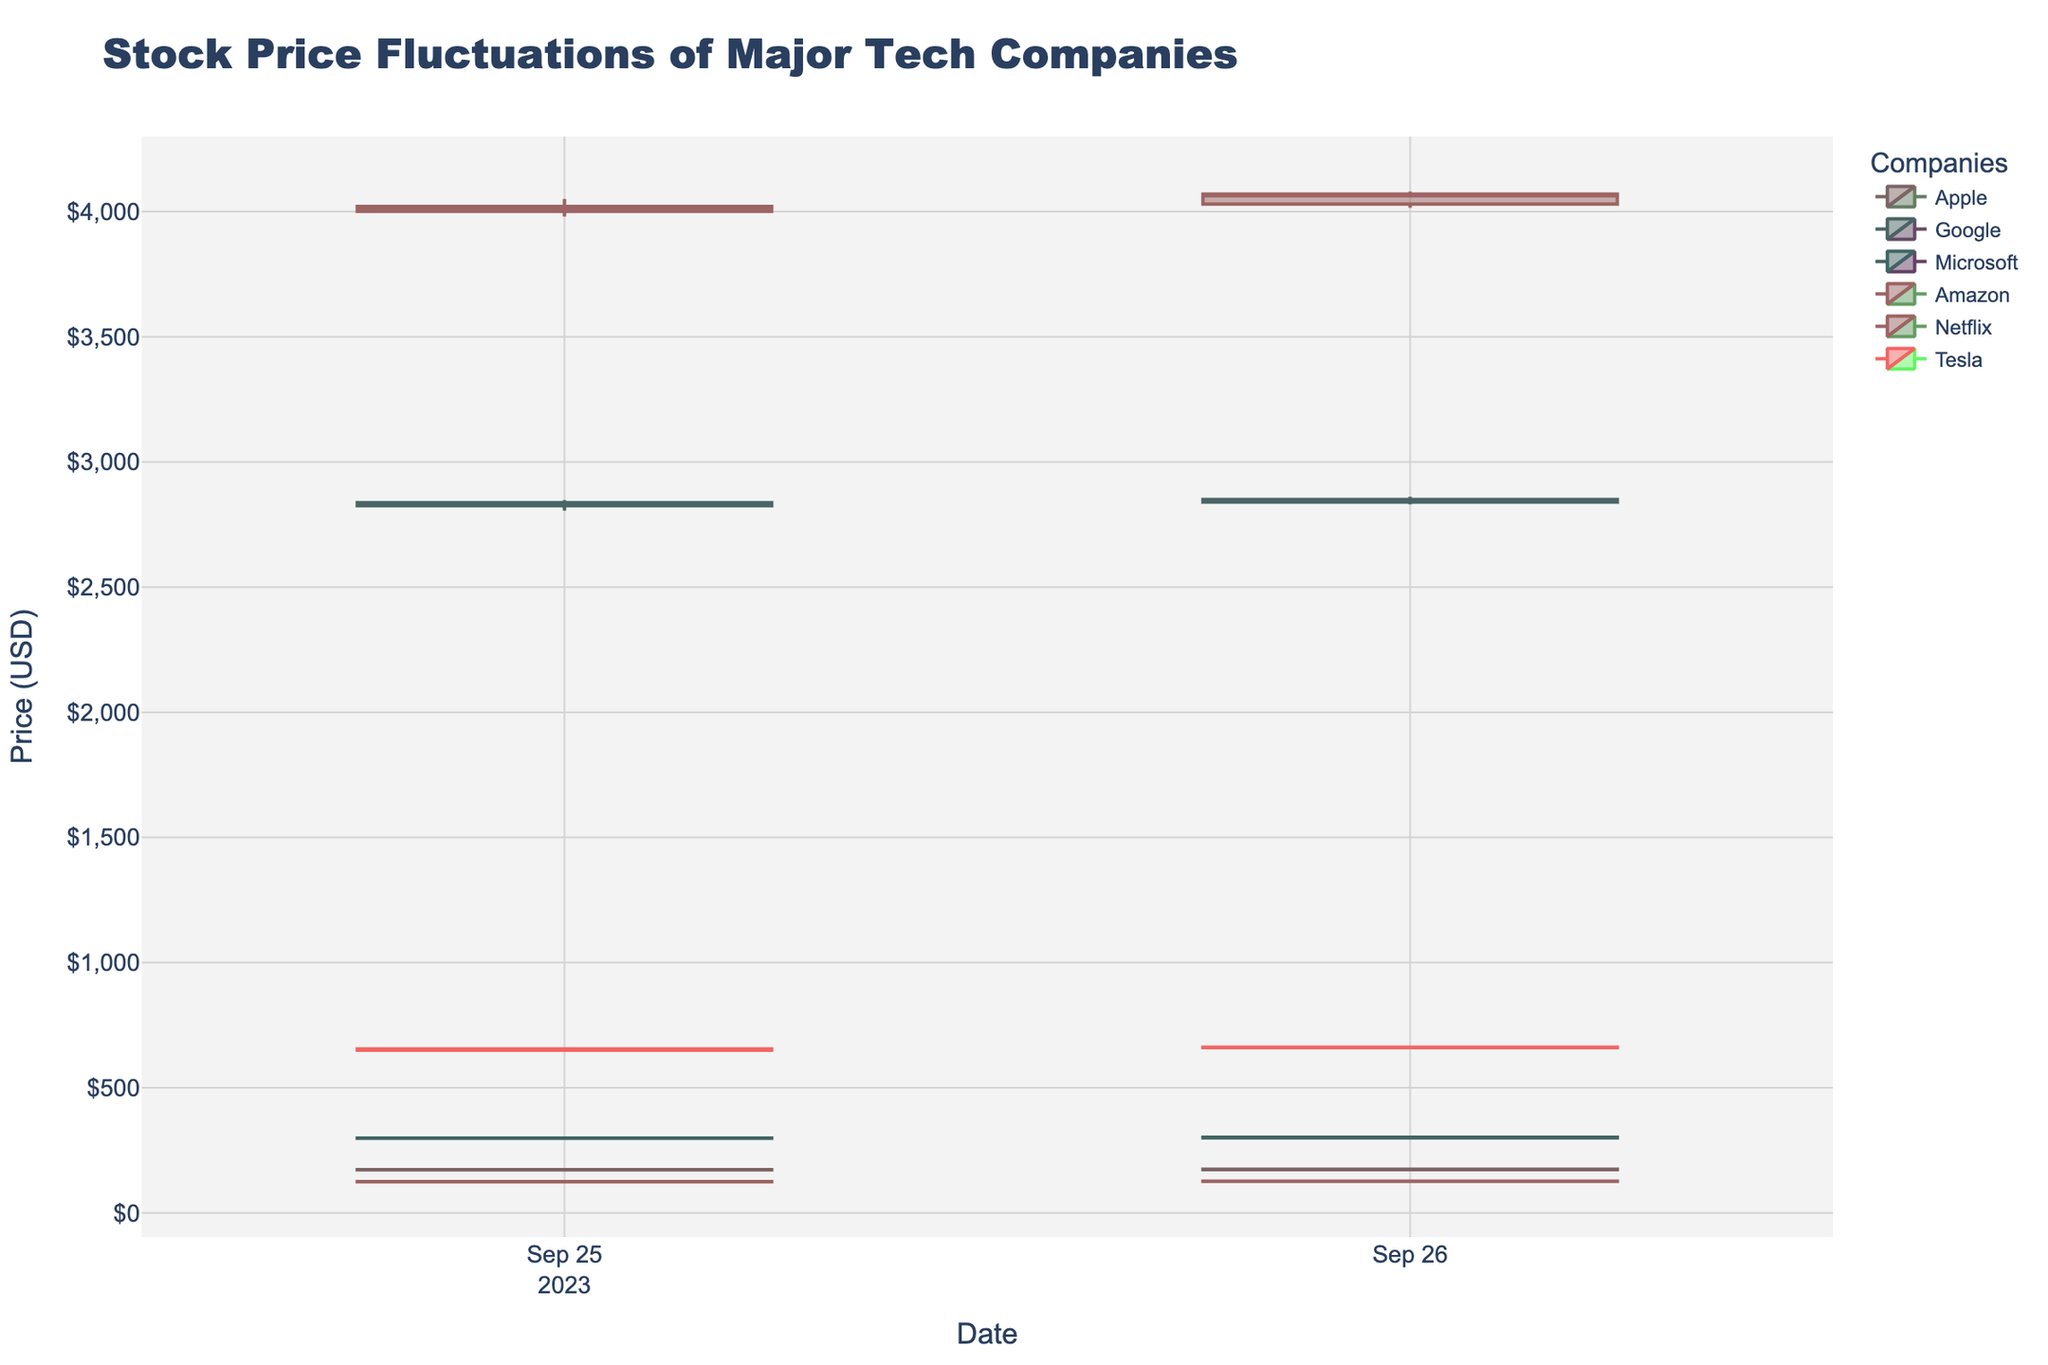What is the title of the figure? The title is prominently displayed at the top of the figure, indicating the main subject of the visualization.
Answer: Stock Price Fluctuations of Major Tech Companies On which date do the data points start? The x-axis contains dates, and the earliest date on the plot is the starting point.
Answer: 2023-09-25 Which company had the highest closing price on September 25th? By observing the highest point of the candlesticks labeled for each company on 2023-09-25, we can identify the highest closing price. For each candlestick, the closing price is the top of the box if the price increased.
Answer: Amazon Which company's stock had the highest opening price on September 26th? The top end of the lower shadow of each candlestick on 2023-09-26 represents the opening price for each company. We need to compare those values.
Answer: Amazon What is the range (difference between high and low) of Microsoft's stock price on September 26th? To find the range, subtract the lowest price (bottom of the shadow) from the highest price (top of the shadow) of the candlestick for Microsoft on 2023-09-26. The high is 303.10, and the low is 298.70.
Answer: 4.40 Between September 25th and 26th, did Netflix's stock price increase or decrease? By comparing the closing prices of Netflix on both dates using the candlesticks, where the closing price is the top if the price went up, or the bottom if it went down.
Answer: Increase Which company had the highest volume of trades on September 25th? The volume of trades is displayed alongside the stock prices. We identify the highest value among all companies for the given date.
Answer: Microsoft What is the closing price difference between Apple and Google on September 25th? Subtract the closing price of Apple from the closing price of Google on 2023-09-25. Apple's closing price: 173.29, Google's closing price: 2836.90
Answer: 2663.61 Did any company's stock close lower on September 26th compared to September 25th? By inspecting the closing price of each company on both dates and comparing them, we determine if the price decreased.
Answer: No Which company displayed the largest single-day price increase between the opening and closing price on September 26th? Calculate the difference between opening and closing prices for each company on 2023-09-26 and compare these differences. Amazon's increase is the largest (4070.20 - 4030.00 = 40.20).
Answer: Amazon 